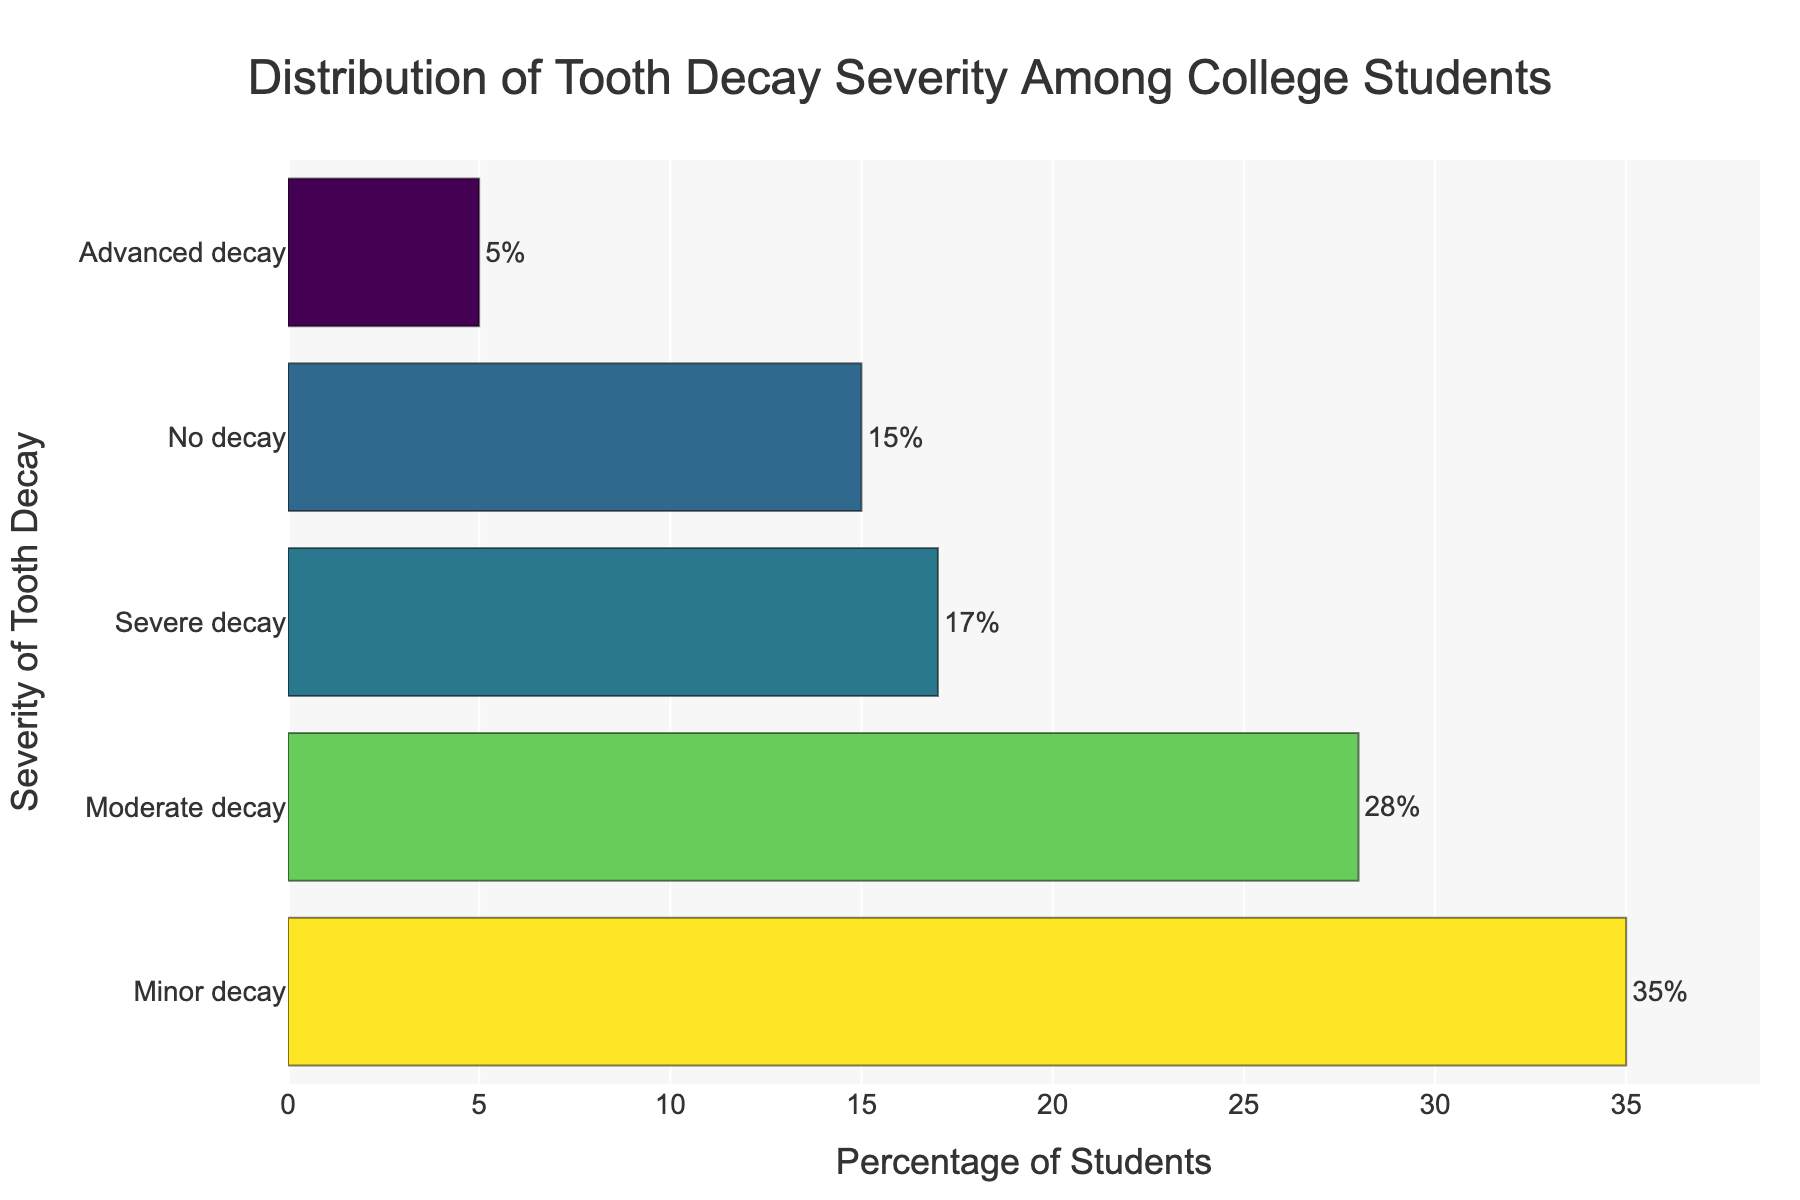What's the title of the figure? The title is at the top of the figure, clearly stated.
Answer: Distribution of Tooth Decay Severity Among College Students What's the highest percentage of students for a given severity of tooth decay? The longest bar represents the most common severity, which has an associated percentage label.
Answer: Minor decay (35%) What's the lowest percentage of students for a given severity of tooth decay? The shortest bar represents the least common severity, which has an associated percentage label.
Answer: Advanced decay (5%) Which severity has the second-highest percentage of students? The second-longest bar corresponds to the severity with the second-highest percentage of students, labeled with that percentage.
Answer: Moderate decay (28%) How many severity categories are shown in the figure? Count the number of distinct bars or y-axis labels representing different severities.
Answer: 5 What is the combined percentage of students with either severe or advanced decay? Add the percentages labeled on the respective bars for severe and advanced decay. 17% + 5% = 22%
Answer: 22% How much higher is the percentage of students with minor decay compared to no decay? Subtract the percentage of no decay from the percentage of minor decay. 35% - 15% = 20%
Answer: 20% Which severity has a coloration indicating the highest value based on the colorscale used? Identify the color associated with the highest value bar (Minor decay) on the colorscale (Viridis).
Answer: Minor decay What is the average percentage of students for the categories of moderate and severe decay? Calculate the average by adding the percentages and dividing by 2. (28% + 17%) / 2 = 22.5%
Answer: 22.5% How is the x-axis labeled in the figure? The x-axis title is positioned at the bottom of the x-axis and describes what the x-axis represents.
Answer: Percentage of Students 